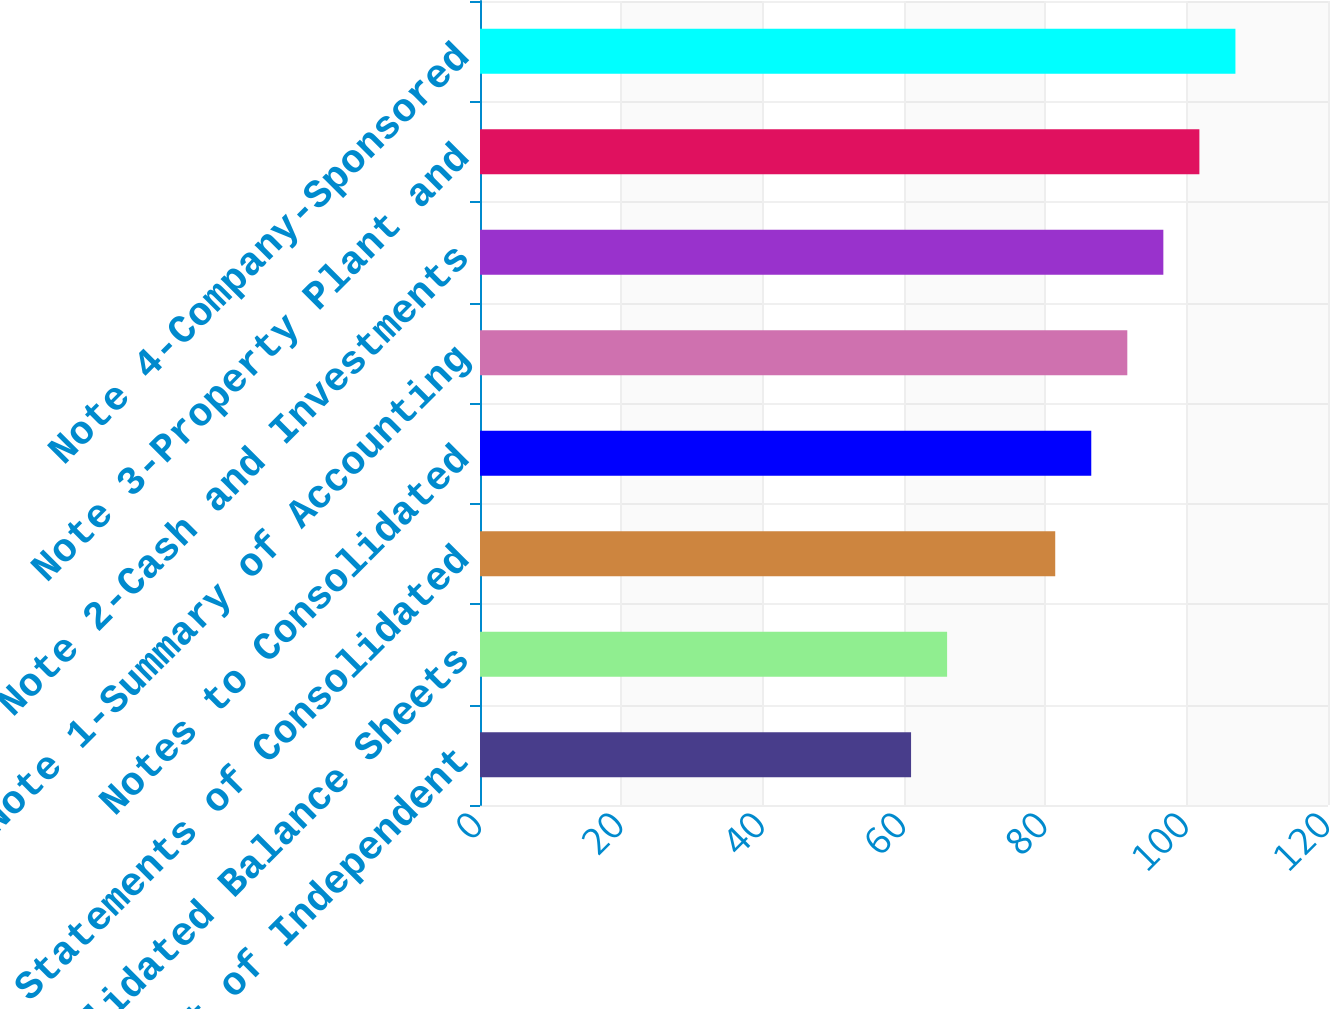<chart> <loc_0><loc_0><loc_500><loc_500><bar_chart><fcel>Report of Independent<fcel>Consolidated Balance Sheets<fcel>Statements of Consolidated<fcel>Notes to Consolidated<fcel>Note 1-Summary of Accounting<fcel>Note 2-Cash and Investments<fcel>Note 3-Property Plant and<fcel>Note 4-Company-Sponsored<nl><fcel>61<fcel>66.1<fcel>81.4<fcel>86.5<fcel>91.6<fcel>96.7<fcel>101.8<fcel>106.9<nl></chart> 